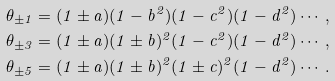<formula> <loc_0><loc_0><loc_500><loc_500>\theta _ { \pm 1 } = ( 1 \pm a ) ( 1 - b ^ { 2 } ) ( 1 - c ^ { 2 } ) ( 1 - d ^ { 2 } ) \cdots , \\ \theta _ { \pm 3 } = ( 1 \pm a ) ( 1 \pm b ) ^ { 2 } ( 1 - c ^ { 2 } ) ( 1 - d ^ { 2 } ) \cdots , \\ \theta _ { \pm 5 } = ( 1 \pm a ) ( 1 \pm b ) ^ { 2 } ( 1 \pm c ) ^ { 2 } ( 1 - d ^ { 2 } ) \cdots .</formula> 